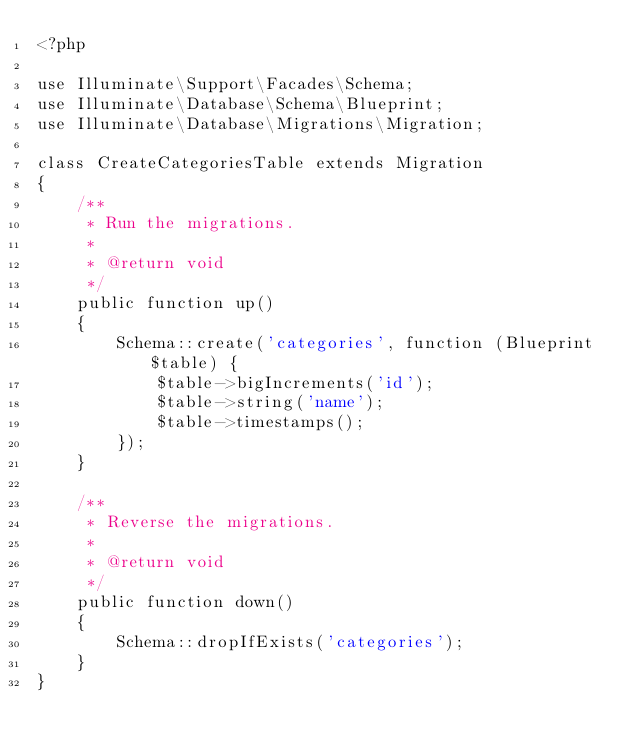Convert code to text. <code><loc_0><loc_0><loc_500><loc_500><_PHP_><?php

use Illuminate\Support\Facades\Schema;
use Illuminate\Database\Schema\Blueprint;
use Illuminate\Database\Migrations\Migration;

class CreateCategoriesTable extends Migration
{
    /**
     * Run the migrations. 
     *
     * @return void
     */
    public function up()
    {
        Schema::create('categories', function (Blueprint $table) {
            $table->bigIncrements('id');
            $table->string('name');
            $table->timestamps();
        });
    }

    /**
     * Reverse the migrations.
     *
     * @return void
     */
    public function down()
    {
        Schema::dropIfExists('categories');
    }
}
</code> 